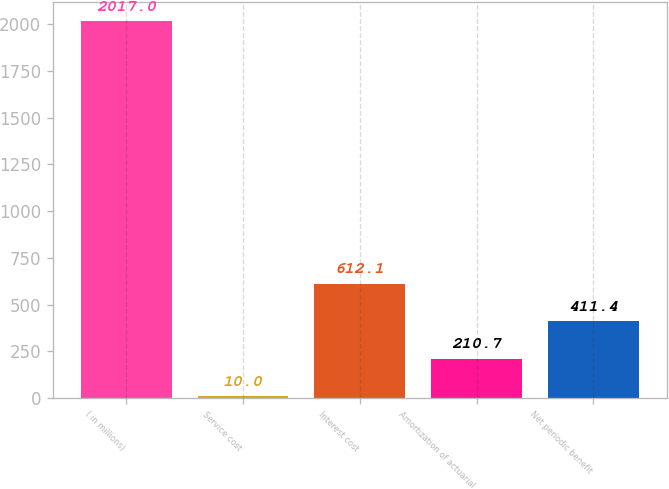Convert chart. <chart><loc_0><loc_0><loc_500><loc_500><bar_chart><fcel>( in millions)<fcel>Service cost<fcel>Interest cost<fcel>Amortization of actuarial<fcel>Net periodic benefit<nl><fcel>2017<fcel>10<fcel>612.1<fcel>210.7<fcel>411.4<nl></chart> 